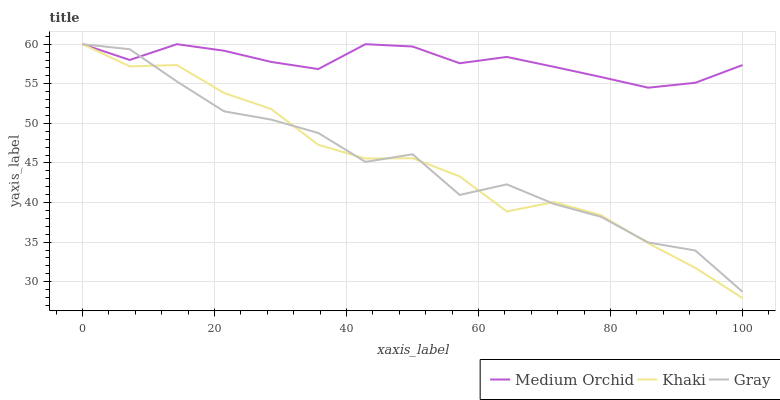Does Khaki have the minimum area under the curve?
Answer yes or no. Yes. Does Medium Orchid have the maximum area under the curve?
Answer yes or no. Yes. Does Medium Orchid have the minimum area under the curve?
Answer yes or no. No. Does Khaki have the maximum area under the curve?
Answer yes or no. No. Is Medium Orchid the smoothest?
Answer yes or no. Yes. Is Gray the roughest?
Answer yes or no. Yes. Is Khaki the smoothest?
Answer yes or no. No. Is Khaki the roughest?
Answer yes or no. No. Does Khaki have the lowest value?
Answer yes or no. Yes. Does Medium Orchid have the lowest value?
Answer yes or no. No. Does Khaki have the highest value?
Answer yes or no. Yes. Does Khaki intersect Gray?
Answer yes or no. Yes. Is Khaki less than Gray?
Answer yes or no. No. Is Khaki greater than Gray?
Answer yes or no. No. 